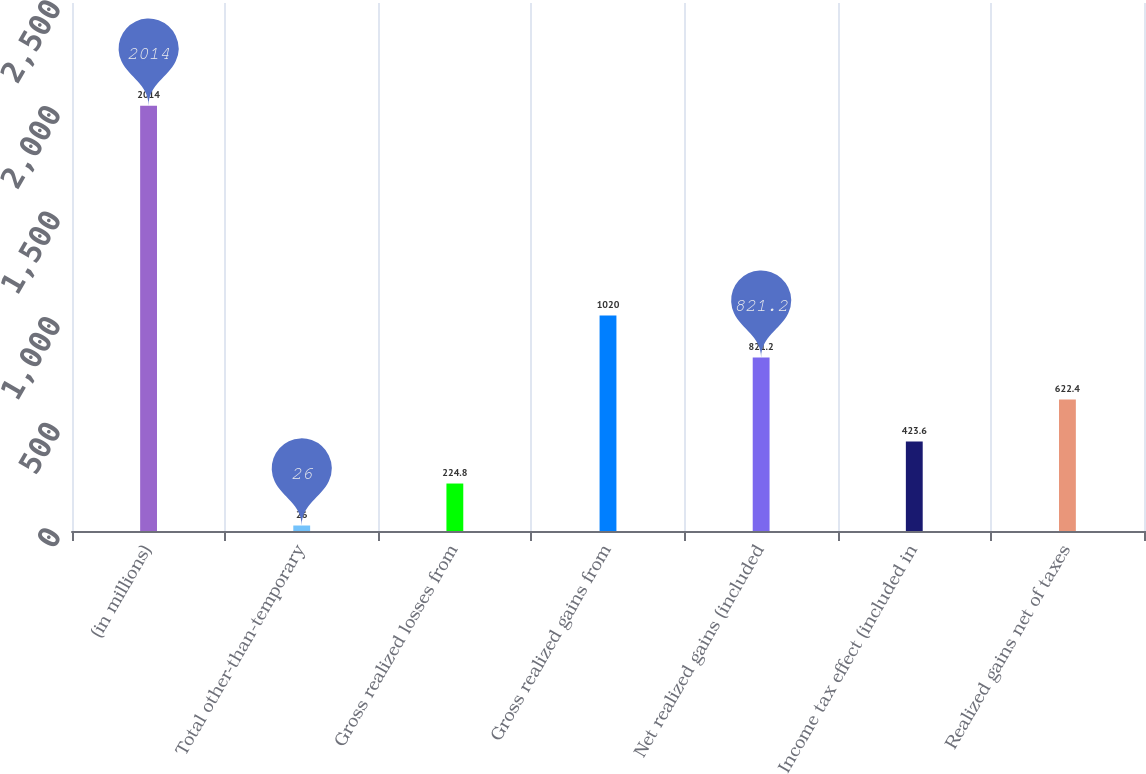<chart> <loc_0><loc_0><loc_500><loc_500><bar_chart><fcel>(in millions)<fcel>Total other-than-temporary<fcel>Gross realized losses from<fcel>Gross realized gains from<fcel>Net realized gains (included<fcel>Income tax effect (included in<fcel>Realized gains net of taxes<nl><fcel>2014<fcel>26<fcel>224.8<fcel>1020<fcel>821.2<fcel>423.6<fcel>622.4<nl></chart> 